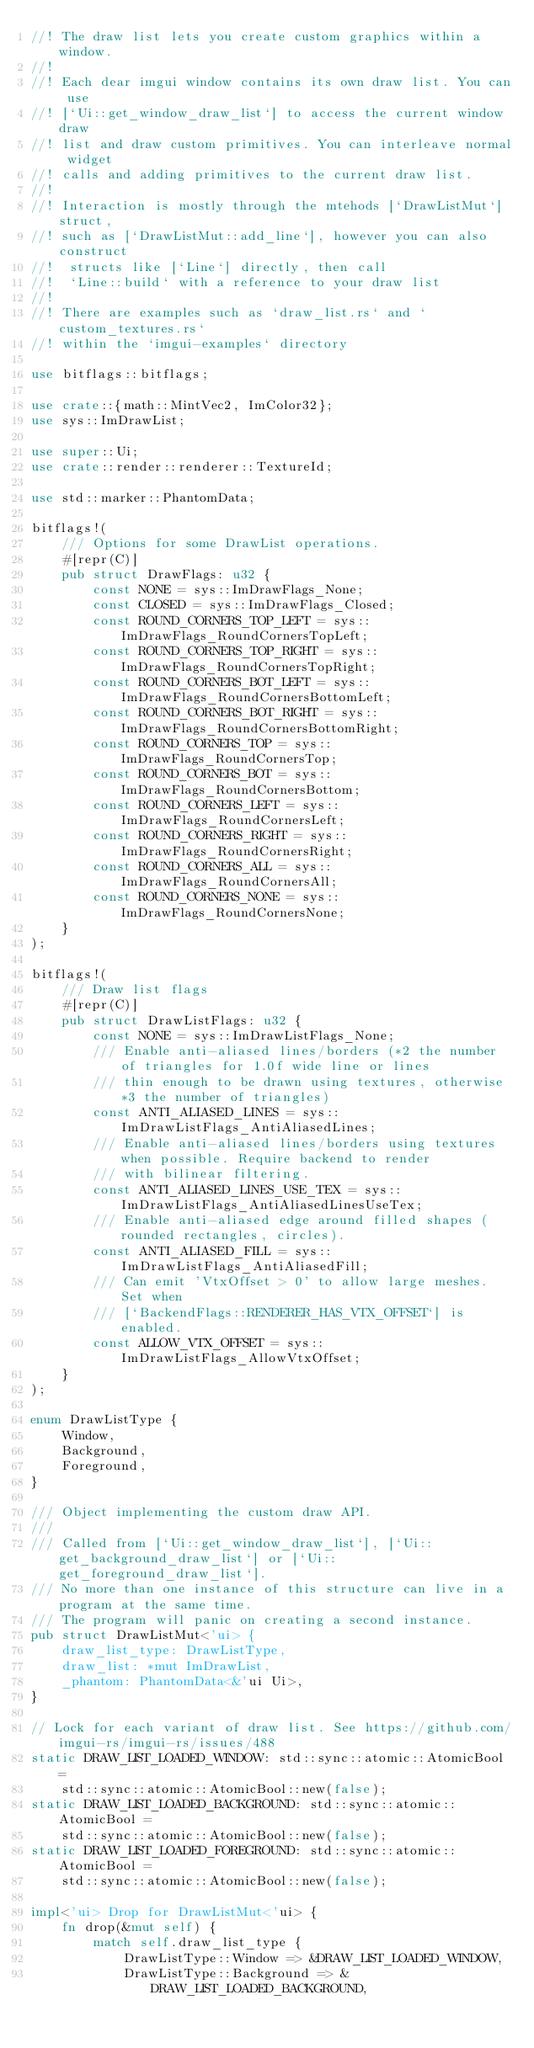Convert code to text. <code><loc_0><loc_0><loc_500><loc_500><_Rust_>//! The draw list lets you create custom graphics within a window.
//!
//! Each dear imgui window contains its own draw list. You can use
//! [`Ui::get_window_draw_list`] to access the current window draw
//! list and draw custom primitives. You can interleave normal widget
//! calls and adding primitives to the current draw list.
//!
//! Interaction is mostly through the mtehods [`DrawListMut`] struct,
//! such as [`DrawListMut::add_line`], however you can also construct
//!  structs like [`Line`] directly, then call
//!  `Line::build` with a reference to your draw list
//!
//! There are examples such as `draw_list.rs` and `custom_textures.rs`
//! within the `imgui-examples` directory

use bitflags::bitflags;

use crate::{math::MintVec2, ImColor32};
use sys::ImDrawList;

use super::Ui;
use crate::render::renderer::TextureId;

use std::marker::PhantomData;

bitflags!(
    /// Options for some DrawList operations.
    #[repr(C)]
    pub struct DrawFlags: u32 {
        const NONE = sys::ImDrawFlags_None;
        const CLOSED = sys::ImDrawFlags_Closed;
        const ROUND_CORNERS_TOP_LEFT = sys::ImDrawFlags_RoundCornersTopLeft;
        const ROUND_CORNERS_TOP_RIGHT = sys::ImDrawFlags_RoundCornersTopRight;
        const ROUND_CORNERS_BOT_LEFT = sys::ImDrawFlags_RoundCornersBottomLeft;
        const ROUND_CORNERS_BOT_RIGHT = sys::ImDrawFlags_RoundCornersBottomRight;
        const ROUND_CORNERS_TOP = sys::ImDrawFlags_RoundCornersTop;
        const ROUND_CORNERS_BOT = sys::ImDrawFlags_RoundCornersBottom;
        const ROUND_CORNERS_LEFT = sys::ImDrawFlags_RoundCornersLeft;
        const ROUND_CORNERS_RIGHT = sys::ImDrawFlags_RoundCornersRight;
        const ROUND_CORNERS_ALL = sys::ImDrawFlags_RoundCornersAll;
        const ROUND_CORNERS_NONE = sys::ImDrawFlags_RoundCornersNone;
    }
);

bitflags!(
    /// Draw list flags
    #[repr(C)]
    pub struct DrawListFlags: u32 {
        const NONE = sys::ImDrawListFlags_None;
        /// Enable anti-aliased lines/borders (*2 the number of triangles for 1.0f wide line or lines
        /// thin enough to be drawn using textures, otherwise *3 the number of triangles)
        const ANTI_ALIASED_LINES = sys::ImDrawListFlags_AntiAliasedLines;
        /// Enable anti-aliased lines/borders using textures when possible. Require backend to render
        /// with bilinear filtering.
        const ANTI_ALIASED_LINES_USE_TEX = sys::ImDrawListFlags_AntiAliasedLinesUseTex;
        /// Enable anti-aliased edge around filled shapes (rounded rectangles, circles).
        const ANTI_ALIASED_FILL = sys::ImDrawListFlags_AntiAliasedFill;
        /// Can emit 'VtxOffset > 0' to allow large meshes. Set when
        /// [`BackendFlags::RENDERER_HAS_VTX_OFFSET`] is enabled.
        const ALLOW_VTX_OFFSET = sys::ImDrawListFlags_AllowVtxOffset;
    }
);

enum DrawListType {
    Window,
    Background,
    Foreground,
}

/// Object implementing the custom draw API.
///
/// Called from [`Ui::get_window_draw_list`], [`Ui::get_background_draw_list`] or [`Ui::get_foreground_draw_list`].
/// No more than one instance of this structure can live in a program at the same time.
/// The program will panic on creating a second instance.
pub struct DrawListMut<'ui> {
    draw_list_type: DrawListType,
    draw_list: *mut ImDrawList,
    _phantom: PhantomData<&'ui Ui>,
}

// Lock for each variant of draw list. See https://github.com/imgui-rs/imgui-rs/issues/488
static DRAW_LIST_LOADED_WINDOW: std::sync::atomic::AtomicBool =
    std::sync::atomic::AtomicBool::new(false);
static DRAW_LIST_LOADED_BACKGROUND: std::sync::atomic::AtomicBool =
    std::sync::atomic::AtomicBool::new(false);
static DRAW_LIST_LOADED_FOREGROUND: std::sync::atomic::AtomicBool =
    std::sync::atomic::AtomicBool::new(false);

impl<'ui> Drop for DrawListMut<'ui> {
    fn drop(&mut self) {
        match self.draw_list_type {
            DrawListType::Window => &DRAW_LIST_LOADED_WINDOW,
            DrawListType::Background => &DRAW_LIST_LOADED_BACKGROUND,</code> 